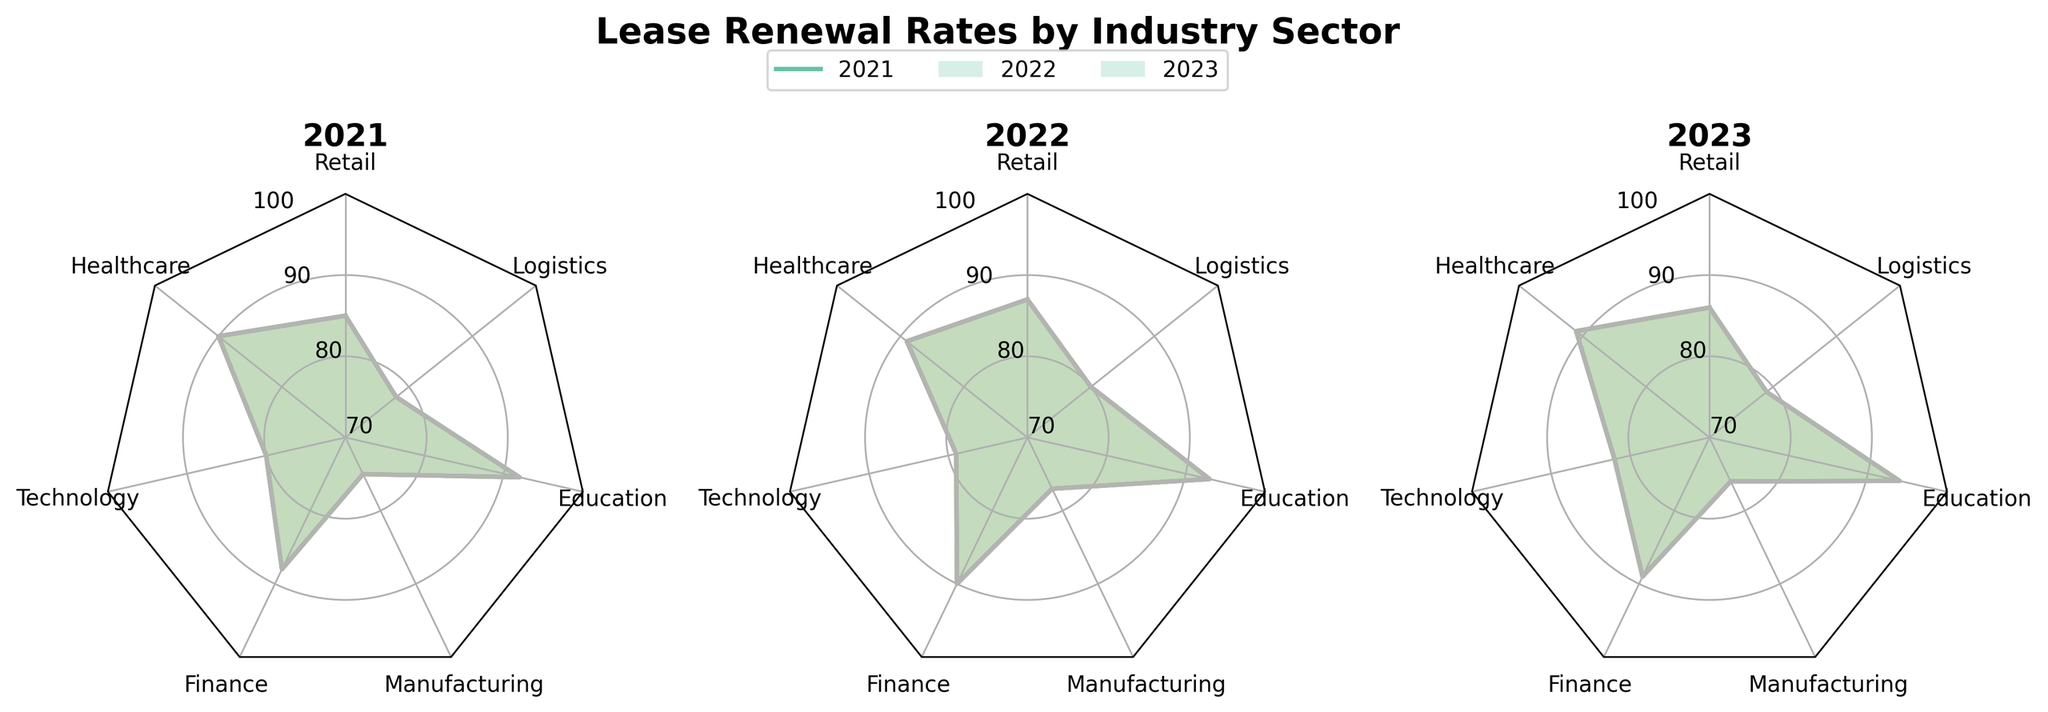How many different industry sectors are displayed in the radar charts? Count the number of sector labels around the perimeter of the radar charts.
Answer: 7 Which industry sector had the highest renewal rate in 2023? Look at the plot for the year 2023 and identify the sector corresponding to the outermost point.
Answer: Education Did the retail sector's renewal rate increase, decrease, or remain the same from 2021 to 2023? Track the position of the Retail sector point across the three plots (2021, 2022, 2023).
Answer: Remain the same Which year shows the highest average renewal rate across all industry sectors? Calculate the average renewal rate for each year by visually estimating the average distance of points from the center in each subplot.
Answer: 2023 What is the renewal rate for the Logistics sector in 2021? Find the Logistics sector label in the 2021 radar chart and read the value on the corresponding axis.
Answer: 78 Compare the renewal rates of the Finance and Healthcare sectors in 2022. Which one is higher? Find both sectors in the 2022 chart and compare their positions on the axis.
Answer: Finance Did the Manufacturing sector's renewal rate change consistently each year from 2021 to 2023? Observe the progression of the Manufacturing sector points across 2021, 2022, and 2023 subplots.
Answer: No What overall trend can be observed in the Education sector's renewal rate from 2021 to 2023? Follow the Education sector's point across the three years and note the direction of change.
Answer: Increasing Between 2021 and 2023, which sector saw the largest improvement in renewal rates? Compare the renewal rates for each sector in 2021 and 2023 and identify the sector with the largest increase.
Answer: Logistics In which year did the Technology sector have its lowest renewal rate? Look for the Technology sector's point in each of the three subplots and identify the year with the lowest value.
Answer: 2022 